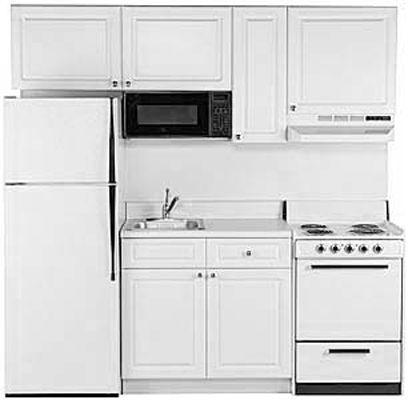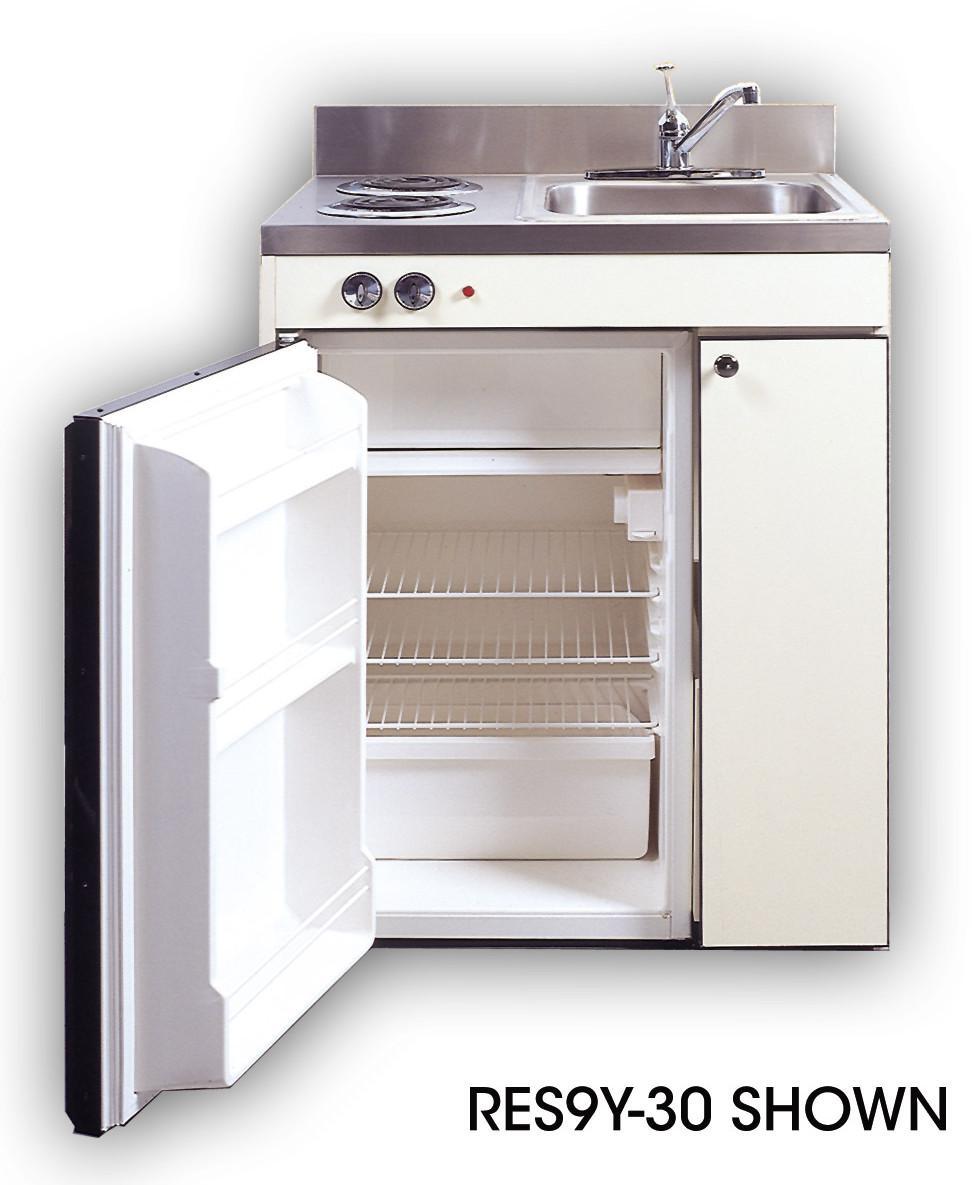The first image is the image on the left, the second image is the image on the right. Given the left and right images, does the statement "Only one refrigerator has its door open, and it has no contents within." hold true? Answer yes or no. Yes. The first image is the image on the left, the second image is the image on the right. For the images displayed, is the sentence "One refrigerator door is all the way wide open and the door shelves are showing." factually correct? Answer yes or no. Yes. 